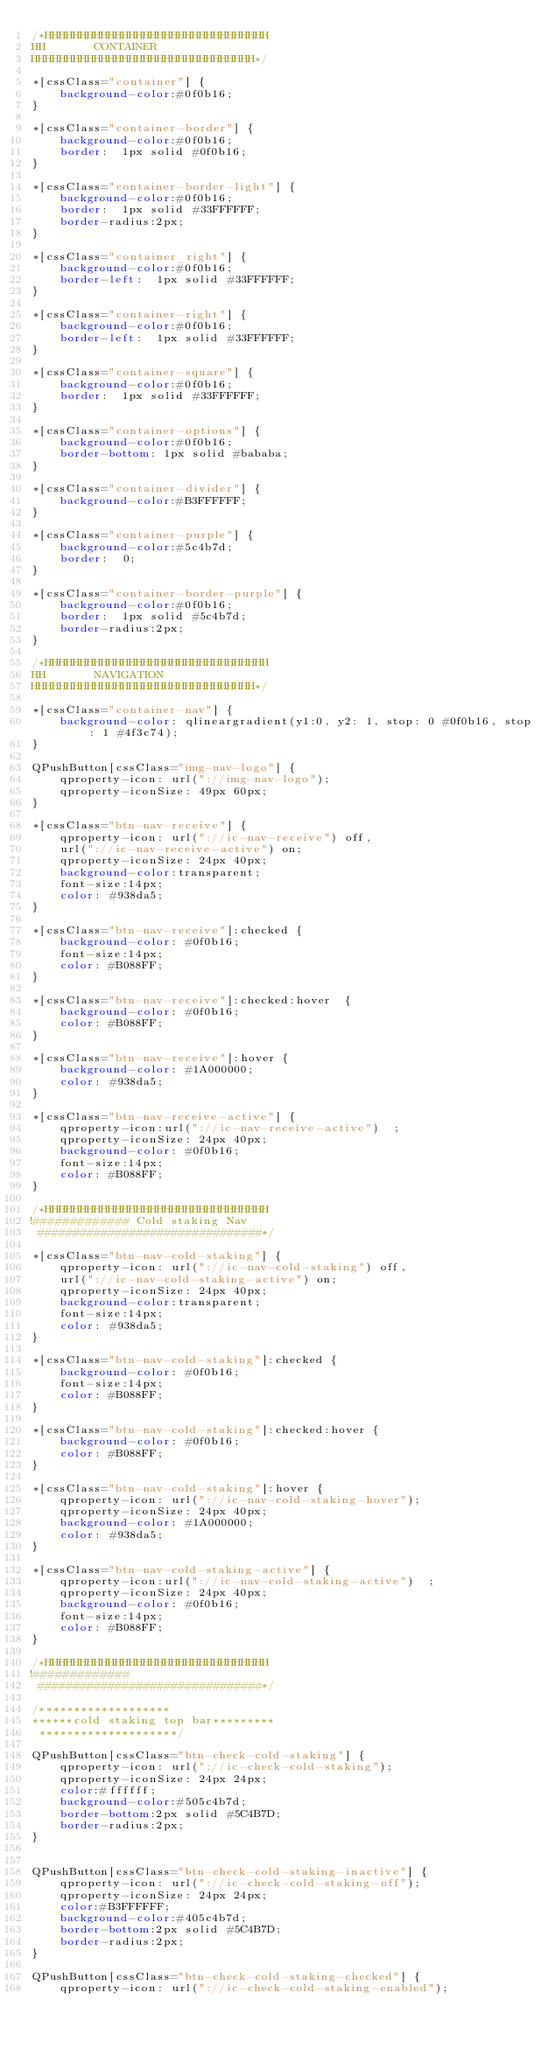<code> <loc_0><loc_0><loc_500><loc_500><_CSS_>/*HHHHHHHHHHHHHHHHHHHHHHHHHHHHHHHH
HH       CONTAINER
HHHHHHHHHHHHHHHHHHHHHHHHHHHHHHHH*/

*[cssClass="container"] {
    background-color:#0f0b16;
}

*[cssClass="container-border"] {
    background-color:#0f0b16;
    border:  1px solid #0f0b16;
}

*[cssClass="container-border-light"] {
    background-color:#0f0b16;
    border:  1px solid #33FFFFFF;
    border-radius:2px;
}

*[cssClass="container_right"] {
    background-color:#0f0b16;
    border-left:  1px solid #33FFFFFF;
}

*[cssClass="container-right"] {
    background-color:#0f0b16;
    border-left:  1px solid #33FFFFFF;
}

*[cssClass="container-square"] {
    background-color:#0f0b16;
    border:  1px solid #33FFFFFF;
}

*[cssClass="container-options"] {
    background-color:#0f0b16;
    border-bottom: 1px solid #bababa;
}

*[cssClass="container-divider"] {
    background-color:#B3FFFFFF;
}

*[cssClass="container-purple"] {
    background-color:#5c4b7d;
    border:  0;
}

*[cssClass="container-border-purple"] {
    background-color:#0f0b16;
    border:  1px solid #5c4b7d;
    border-radius:2px;
}

/*HHHHHHHHHHHHHHHHHHHHHHHHHHHHHHHH
HH       NAVIGATION
HHHHHHHHHHHHHHHHHHHHHHHHHHHHHHHH*/

*[cssClass="container-nav"] {
    background-color: qlineargradient(y1:0, y2: 1, stop: 0 #0f0b16, stop: 1 #4f3c74);
}

QPushButton[cssClass="img-nav-logo"] {
    qproperty-icon: url("://img-nav-logo");
    qproperty-iconSize: 49px 60px;
}

*[cssClass="btn-nav-receive"] {
    qproperty-icon: url("://ic-nav-receive") off,
    url("://ic-nav-receive-active") on;
    qproperty-iconSize: 24px 40px;
    background-color:transparent;
    font-size:14px;
    color: #938da5;
}

*[cssClass="btn-nav-receive"]:checked {
    background-color: #0f0b16;
    font-size:14px;
    color: #B088FF;
}

*[cssClass="btn-nav-receive"]:checked:hover  {
    background-color: #0f0b16;
    color: #B088FF;
}

*[cssClass="btn-nav-receive"]:hover {
    background-color: #1A000000;
    color: #938da5;
}

*[cssClass="btn-nav-receive-active"] {
    qproperty-icon:url("://ic-nav-receive-active")  ;
    qproperty-iconSize: 24px 40px;
    background-color: #0f0b16;
    font-size:14px;
    color: #B088FF;
}

/*HHHHHHHHHHHHHHHHHHHHHHHHHHHHHHHH
!############# Cold staking Nav
 ################################*/

*[cssClass="btn-nav-cold-staking"] {
    qproperty-icon: url("://ic-nav-cold-staking") off,
    url("://ic-nav-cold-staking-active") on;
    qproperty-iconSize: 24px 40px;
    background-color:transparent;
    font-size:14px;
    color: #938da5;
}

*[cssClass="btn-nav-cold-staking"]:checked {
    background-color: #0f0b16;
    font-size:14px;
    color: #B088FF;
}

*[cssClass="btn-nav-cold-staking"]:checked:hover {
    background-color: #0f0b16;
    color: #B088FF;
}

*[cssClass="btn-nav-cold-staking"]:hover {
    qproperty-icon: url("://ic-nav-cold-staking-hover");
    qproperty-iconSize: 24px 40px;
    background-color: #1A000000;
    color: #938da5;
}

*[cssClass="btn-nav-cold-staking-active"] {
    qproperty-icon:url("://ic-nav-cold-staking-active")  ;
    qproperty-iconSize: 24px 40px;
    background-color: #0f0b16;
    font-size:14px;
    color: #B088FF;
}

/*HHHHHHHHHHHHHHHHHHHHHHHHHHHHHHHH
!#############
 ################################*/

/*******************
******cold staking top bar*********
 ********************/

QPushButton[cssClass="btn-check-cold-staking"] {
    qproperty-icon: url("://ic-check-cold-staking");
    qproperty-iconSize: 24px 24px;
    color:#ffffff;
    background-color:#505c4b7d;
    border-bottom:2px solid #5C4B7D;
    border-radius:2px;
}


QPushButton[cssClass="btn-check-cold-staking-inactive"] {
    qproperty-icon: url("://ic-check-cold-staking-off");
    qproperty-iconSize: 24px 24px;
    color:#B3FFFFFF;
    background-color:#405c4b7d;
    border-bottom:2px solid #5C4B7D;
    border-radius:2px;
}

QPushButton[cssClass="btn-check-cold-staking-checked"] {
    qproperty-icon: url("://ic-check-cold-staking-enabled");</code> 